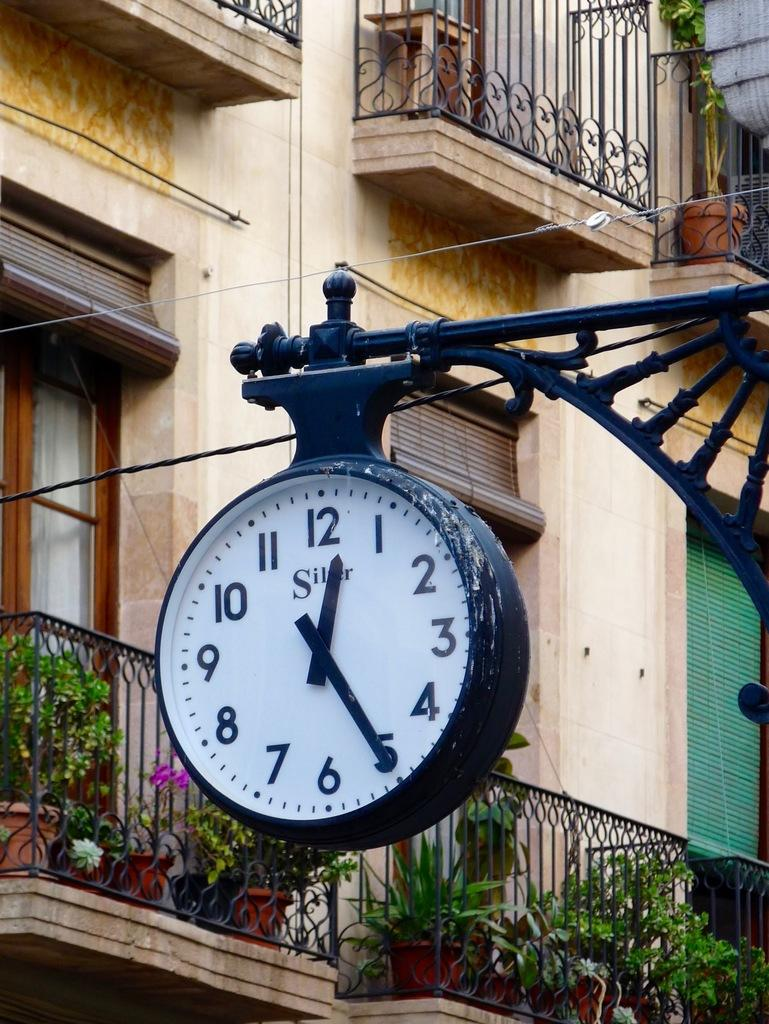<image>
Create a compact narrative representing the image presented. A clock with SILVER written on it points to the numbers 12 and 5 